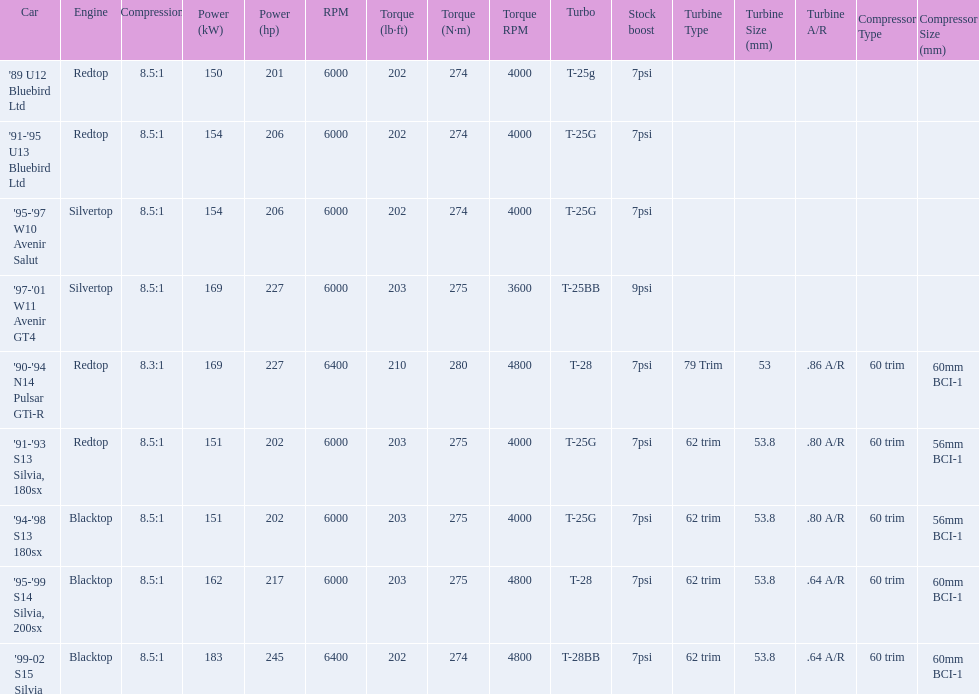Which car's power measured at higher than 6000 rpm? '90-'94 N14 Pulsar GTi-R, '99-02 S15 Silvia. 